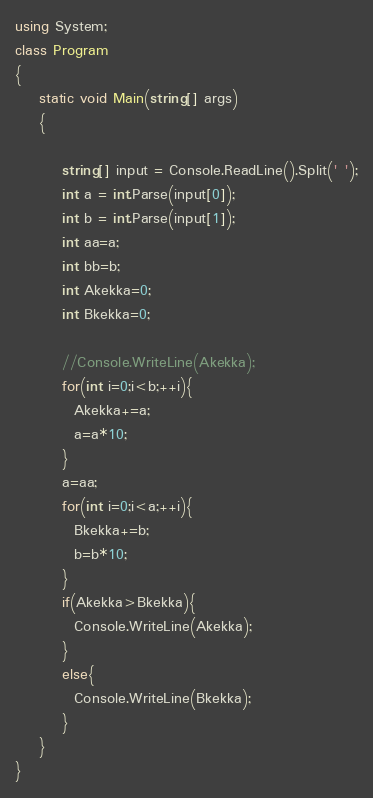<code> <loc_0><loc_0><loc_500><loc_500><_C#_>using System;
class Program
{
	static void Main(string[] args)
	{
		
		string[] input = Console.ReadLine().Split(' ');
		int a = int.Parse(input[0]);
		int b = int.Parse(input[1]);
        int aa=a;
        int bb=b;
        int Akekka=0;
        int Bkekka=0;
        
        //Console.WriteLine(Akekka);
		for(int i=0;i<b;++i){
          Akekka+=a;
          a=a*10;
        }
        a=aa;
        for(int i=0;i<a;++i){
          Bkekka+=b;
          b=b*10;
        }
        if(Akekka>Bkekka){
          Console.WriteLine(Akekka);
        }
        else{
          Console.WriteLine(Bkekka);
        }
	}
}</code> 